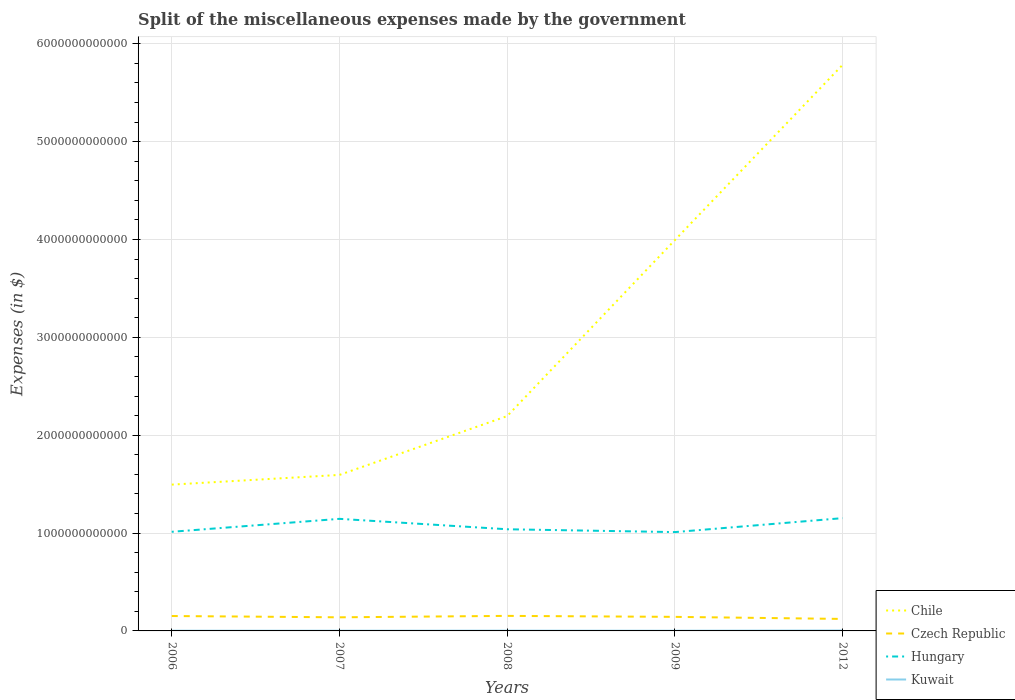Does the line corresponding to Hungary intersect with the line corresponding to Czech Republic?
Ensure brevity in your answer.  No. Across all years, what is the maximum miscellaneous expenses made by the government in Kuwait?
Offer a terse response. 1.95e+09. In which year was the miscellaneous expenses made by the government in Czech Republic maximum?
Your answer should be very brief. 2012. What is the total miscellaneous expenses made by the government in Kuwait in the graph?
Your response must be concise. 6.62e+08. What is the difference between the highest and the second highest miscellaneous expenses made by the government in Kuwait?
Offer a terse response. 2.01e+09. What is the difference between the highest and the lowest miscellaneous expenses made by the government in Chile?
Provide a succinct answer. 2. Is the miscellaneous expenses made by the government in Kuwait strictly greater than the miscellaneous expenses made by the government in Hungary over the years?
Make the answer very short. Yes. How many years are there in the graph?
Make the answer very short. 5. What is the difference between two consecutive major ticks on the Y-axis?
Your response must be concise. 1.00e+12. How many legend labels are there?
Your answer should be compact. 4. How are the legend labels stacked?
Your response must be concise. Vertical. What is the title of the graph?
Keep it short and to the point. Split of the miscellaneous expenses made by the government. What is the label or title of the Y-axis?
Your answer should be very brief. Expenses (in $). What is the Expenses (in $) in Chile in 2006?
Make the answer very short. 1.50e+12. What is the Expenses (in $) of Czech Republic in 2006?
Your answer should be very brief. 1.52e+11. What is the Expenses (in $) in Hungary in 2006?
Provide a short and direct response. 1.01e+12. What is the Expenses (in $) of Kuwait in 2006?
Your answer should be compact. 2.00e+09. What is the Expenses (in $) of Chile in 2007?
Provide a succinct answer. 1.59e+12. What is the Expenses (in $) of Czech Republic in 2007?
Offer a terse response. 1.39e+11. What is the Expenses (in $) in Hungary in 2007?
Your answer should be compact. 1.15e+12. What is the Expenses (in $) in Kuwait in 2007?
Offer a very short reply. 2.09e+09. What is the Expenses (in $) of Chile in 2008?
Your response must be concise. 2.20e+12. What is the Expenses (in $) of Czech Republic in 2008?
Offer a terse response. 1.54e+11. What is the Expenses (in $) in Hungary in 2008?
Offer a terse response. 1.04e+12. What is the Expenses (in $) of Kuwait in 2008?
Make the answer very short. 2.62e+09. What is the Expenses (in $) in Chile in 2009?
Give a very brief answer. 3.99e+12. What is the Expenses (in $) in Czech Republic in 2009?
Your response must be concise. 1.44e+11. What is the Expenses (in $) of Hungary in 2009?
Your answer should be very brief. 1.01e+12. What is the Expenses (in $) in Kuwait in 2009?
Your answer should be compact. 1.95e+09. What is the Expenses (in $) of Chile in 2012?
Provide a short and direct response. 5.78e+12. What is the Expenses (in $) in Czech Republic in 2012?
Keep it short and to the point. 1.22e+11. What is the Expenses (in $) in Hungary in 2012?
Provide a short and direct response. 1.15e+12. What is the Expenses (in $) of Kuwait in 2012?
Make the answer very short. 3.96e+09. Across all years, what is the maximum Expenses (in $) in Chile?
Keep it short and to the point. 5.78e+12. Across all years, what is the maximum Expenses (in $) in Czech Republic?
Ensure brevity in your answer.  1.54e+11. Across all years, what is the maximum Expenses (in $) in Hungary?
Provide a succinct answer. 1.15e+12. Across all years, what is the maximum Expenses (in $) in Kuwait?
Your response must be concise. 3.96e+09. Across all years, what is the minimum Expenses (in $) of Chile?
Provide a succinct answer. 1.50e+12. Across all years, what is the minimum Expenses (in $) in Czech Republic?
Give a very brief answer. 1.22e+11. Across all years, what is the minimum Expenses (in $) of Hungary?
Ensure brevity in your answer.  1.01e+12. Across all years, what is the minimum Expenses (in $) in Kuwait?
Offer a terse response. 1.95e+09. What is the total Expenses (in $) of Chile in the graph?
Give a very brief answer. 1.51e+13. What is the total Expenses (in $) of Czech Republic in the graph?
Your answer should be very brief. 7.11e+11. What is the total Expenses (in $) of Hungary in the graph?
Offer a very short reply. 5.36e+12. What is the total Expenses (in $) of Kuwait in the graph?
Provide a short and direct response. 1.26e+1. What is the difference between the Expenses (in $) in Chile in 2006 and that in 2007?
Make the answer very short. -9.92e+1. What is the difference between the Expenses (in $) in Czech Republic in 2006 and that in 2007?
Make the answer very short. 1.33e+1. What is the difference between the Expenses (in $) in Hungary in 2006 and that in 2007?
Offer a terse response. -1.32e+11. What is the difference between the Expenses (in $) of Kuwait in 2006 and that in 2007?
Offer a terse response. -8.40e+07. What is the difference between the Expenses (in $) of Chile in 2006 and that in 2008?
Your answer should be very brief. -7.00e+11. What is the difference between the Expenses (in $) in Czech Republic in 2006 and that in 2008?
Provide a succinct answer. -1.35e+09. What is the difference between the Expenses (in $) in Hungary in 2006 and that in 2008?
Your answer should be very brief. -2.59e+1. What is the difference between the Expenses (in $) of Kuwait in 2006 and that in 2008?
Keep it short and to the point. -6.12e+08. What is the difference between the Expenses (in $) in Chile in 2006 and that in 2009?
Offer a terse response. -2.50e+12. What is the difference between the Expenses (in $) in Czech Republic in 2006 and that in 2009?
Your answer should be very brief. 8.73e+09. What is the difference between the Expenses (in $) of Hungary in 2006 and that in 2009?
Offer a terse response. 3.08e+09. What is the difference between the Expenses (in $) of Chile in 2006 and that in 2012?
Your answer should be very brief. -4.29e+12. What is the difference between the Expenses (in $) in Czech Republic in 2006 and that in 2012?
Your answer should be very brief. 2.99e+1. What is the difference between the Expenses (in $) of Hungary in 2006 and that in 2012?
Ensure brevity in your answer.  -1.40e+11. What is the difference between the Expenses (in $) in Kuwait in 2006 and that in 2012?
Offer a very short reply. -1.96e+09. What is the difference between the Expenses (in $) of Chile in 2007 and that in 2008?
Provide a succinct answer. -6.01e+11. What is the difference between the Expenses (in $) in Czech Republic in 2007 and that in 2008?
Your response must be concise. -1.46e+1. What is the difference between the Expenses (in $) of Hungary in 2007 and that in 2008?
Your answer should be compact. 1.06e+11. What is the difference between the Expenses (in $) of Kuwait in 2007 and that in 2008?
Offer a very short reply. -5.28e+08. What is the difference between the Expenses (in $) of Chile in 2007 and that in 2009?
Your answer should be compact. -2.40e+12. What is the difference between the Expenses (in $) of Czech Republic in 2007 and that in 2009?
Ensure brevity in your answer.  -4.55e+09. What is the difference between the Expenses (in $) of Hungary in 2007 and that in 2009?
Your answer should be very brief. 1.35e+11. What is the difference between the Expenses (in $) of Kuwait in 2007 and that in 2009?
Offer a terse response. 1.34e+08. What is the difference between the Expenses (in $) of Chile in 2007 and that in 2012?
Give a very brief answer. -4.19e+12. What is the difference between the Expenses (in $) in Czech Republic in 2007 and that in 2012?
Make the answer very short. 1.66e+1. What is the difference between the Expenses (in $) in Hungary in 2007 and that in 2012?
Offer a terse response. -7.26e+09. What is the difference between the Expenses (in $) of Kuwait in 2007 and that in 2012?
Keep it short and to the point. -1.87e+09. What is the difference between the Expenses (in $) of Chile in 2008 and that in 2009?
Provide a short and direct response. -1.80e+12. What is the difference between the Expenses (in $) in Czech Republic in 2008 and that in 2009?
Keep it short and to the point. 1.01e+1. What is the difference between the Expenses (in $) in Hungary in 2008 and that in 2009?
Offer a very short reply. 2.90e+1. What is the difference between the Expenses (in $) of Kuwait in 2008 and that in 2009?
Give a very brief answer. 6.62e+08. What is the difference between the Expenses (in $) of Chile in 2008 and that in 2012?
Offer a very short reply. -3.59e+12. What is the difference between the Expenses (in $) in Czech Republic in 2008 and that in 2012?
Keep it short and to the point. 3.12e+1. What is the difference between the Expenses (in $) of Hungary in 2008 and that in 2012?
Provide a succinct answer. -1.14e+11. What is the difference between the Expenses (in $) in Kuwait in 2008 and that in 2012?
Offer a very short reply. -1.34e+09. What is the difference between the Expenses (in $) of Chile in 2009 and that in 2012?
Make the answer very short. -1.79e+12. What is the difference between the Expenses (in $) of Czech Republic in 2009 and that in 2012?
Your answer should be compact. 2.12e+1. What is the difference between the Expenses (in $) in Hungary in 2009 and that in 2012?
Offer a very short reply. -1.43e+11. What is the difference between the Expenses (in $) in Kuwait in 2009 and that in 2012?
Give a very brief answer. -2.01e+09. What is the difference between the Expenses (in $) of Chile in 2006 and the Expenses (in $) of Czech Republic in 2007?
Ensure brevity in your answer.  1.36e+12. What is the difference between the Expenses (in $) in Chile in 2006 and the Expenses (in $) in Hungary in 2007?
Offer a terse response. 3.50e+11. What is the difference between the Expenses (in $) in Chile in 2006 and the Expenses (in $) in Kuwait in 2007?
Offer a terse response. 1.49e+12. What is the difference between the Expenses (in $) in Czech Republic in 2006 and the Expenses (in $) in Hungary in 2007?
Make the answer very short. -9.93e+11. What is the difference between the Expenses (in $) of Czech Republic in 2006 and the Expenses (in $) of Kuwait in 2007?
Provide a short and direct response. 1.50e+11. What is the difference between the Expenses (in $) in Hungary in 2006 and the Expenses (in $) in Kuwait in 2007?
Provide a short and direct response. 1.01e+12. What is the difference between the Expenses (in $) in Chile in 2006 and the Expenses (in $) in Czech Republic in 2008?
Keep it short and to the point. 1.34e+12. What is the difference between the Expenses (in $) of Chile in 2006 and the Expenses (in $) of Hungary in 2008?
Your answer should be compact. 4.56e+11. What is the difference between the Expenses (in $) in Chile in 2006 and the Expenses (in $) in Kuwait in 2008?
Your answer should be very brief. 1.49e+12. What is the difference between the Expenses (in $) in Czech Republic in 2006 and the Expenses (in $) in Hungary in 2008?
Your answer should be compact. -8.86e+11. What is the difference between the Expenses (in $) of Czech Republic in 2006 and the Expenses (in $) of Kuwait in 2008?
Keep it short and to the point. 1.50e+11. What is the difference between the Expenses (in $) of Hungary in 2006 and the Expenses (in $) of Kuwait in 2008?
Offer a terse response. 1.01e+12. What is the difference between the Expenses (in $) of Chile in 2006 and the Expenses (in $) of Czech Republic in 2009?
Offer a terse response. 1.35e+12. What is the difference between the Expenses (in $) of Chile in 2006 and the Expenses (in $) of Hungary in 2009?
Keep it short and to the point. 4.85e+11. What is the difference between the Expenses (in $) of Chile in 2006 and the Expenses (in $) of Kuwait in 2009?
Offer a very short reply. 1.49e+12. What is the difference between the Expenses (in $) of Czech Republic in 2006 and the Expenses (in $) of Hungary in 2009?
Offer a very short reply. -8.58e+11. What is the difference between the Expenses (in $) in Czech Republic in 2006 and the Expenses (in $) in Kuwait in 2009?
Provide a short and direct response. 1.50e+11. What is the difference between the Expenses (in $) in Hungary in 2006 and the Expenses (in $) in Kuwait in 2009?
Provide a succinct answer. 1.01e+12. What is the difference between the Expenses (in $) in Chile in 2006 and the Expenses (in $) in Czech Republic in 2012?
Make the answer very short. 1.37e+12. What is the difference between the Expenses (in $) in Chile in 2006 and the Expenses (in $) in Hungary in 2012?
Keep it short and to the point. 3.42e+11. What is the difference between the Expenses (in $) of Chile in 2006 and the Expenses (in $) of Kuwait in 2012?
Provide a short and direct response. 1.49e+12. What is the difference between the Expenses (in $) in Czech Republic in 2006 and the Expenses (in $) in Hungary in 2012?
Offer a terse response. -1.00e+12. What is the difference between the Expenses (in $) of Czech Republic in 2006 and the Expenses (in $) of Kuwait in 2012?
Keep it short and to the point. 1.48e+11. What is the difference between the Expenses (in $) in Hungary in 2006 and the Expenses (in $) in Kuwait in 2012?
Make the answer very short. 1.01e+12. What is the difference between the Expenses (in $) in Chile in 2007 and the Expenses (in $) in Czech Republic in 2008?
Make the answer very short. 1.44e+12. What is the difference between the Expenses (in $) in Chile in 2007 and the Expenses (in $) in Hungary in 2008?
Ensure brevity in your answer.  5.55e+11. What is the difference between the Expenses (in $) of Chile in 2007 and the Expenses (in $) of Kuwait in 2008?
Offer a terse response. 1.59e+12. What is the difference between the Expenses (in $) in Czech Republic in 2007 and the Expenses (in $) in Hungary in 2008?
Keep it short and to the point. -9.00e+11. What is the difference between the Expenses (in $) in Czech Republic in 2007 and the Expenses (in $) in Kuwait in 2008?
Your answer should be very brief. 1.36e+11. What is the difference between the Expenses (in $) in Hungary in 2007 and the Expenses (in $) in Kuwait in 2008?
Your answer should be very brief. 1.14e+12. What is the difference between the Expenses (in $) of Chile in 2007 and the Expenses (in $) of Czech Republic in 2009?
Keep it short and to the point. 1.45e+12. What is the difference between the Expenses (in $) in Chile in 2007 and the Expenses (in $) in Hungary in 2009?
Ensure brevity in your answer.  5.84e+11. What is the difference between the Expenses (in $) of Chile in 2007 and the Expenses (in $) of Kuwait in 2009?
Your answer should be very brief. 1.59e+12. What is the difference between the Expenses (in $) in Czech Republic in 2007 and the Expenses (in $) in Hungary in 2009?
Offer a terse response. -8.71e+11. What is the difference between the Expenses (in $) in Czech Republic in 2007 and the Expenses (in $) in Kuwait in 2009?
Provide a succinct answer. 1.37e+11. What is the difference between the Expenses (in $) of Hungary in 2007 and the Expenses (in $) of Kuwait in 2009?
Provide a short and direct response. 1.14e+12. What is the difference between the Expenses (in $) of Chile in 2007 and the Expenses (in $) of Czech Republic in 2012?
Keep it short and to the point. 1.47e+12. What is the difference between the Expenses (in $) in Chile in 2007 and the Expenses (in $) in Hungary in 2012?
Provide a short and direct response. 4.42e+11. What is the difference between the Expenses (in $) in Chile in 2007 and the Expenses (in $) in Kuwait in 2012?
Your answer should be very brief. 1.59e+12. What is the difference between the Expenses (in $) in Czech Republic in 2007 and the Expenses (in $) in Hungary in 2012?
Your answer should be very brief. -1.01e+12. What is the difference between the Expenses (in $) in Czech Republic in 2007 and the Expenses (in $) in Kuwait in 2012?
Give a very brief answer. 1.35e+11. What is the difference between the Expenses (in $) of Hungary in 2007 and the Expenses (in $) of Kuwait in 2012?
Your response must be concise. 1.14e+12. What is the difference between the Expenses (in $) in Chile in 2008 and the Expenses (in $) in Czech Republic in 2009?
Your answer should be compact. 2.05e+12. What is the difference between the Expenses (in $) of Chile in 2008 and the Expenses (in $) of Hungary in 2009?
Ensure brevity in your answer.  1.19e+12. What is the difference between the Expenses (in $) in Chile in 2008 and the Expenses (in $) in Kuwait in 2009?
Ensure brevity in your answer.  2.19e+12. What is the difference between the Expenses (in $) of Czech Republic in 2008 and the Expenses (in $) of Hungary in 2009?
Your answer should be very brief. -8.56e+11. What is the difference between the Expenses (in $) of Czech Republic in 2008 and the Expenses (in $) of Kuwait in 2009?
Your response must be concise. 1.52e+11. What is the difference between the Expenses (in $) in Hungary in 2008 and the Expenses (in $) in Kuwait in 2009?
Give a very brief answer. 1.04e+12. What is the difference between the Expenses (in $) of Chile in 2008 and the Expenses (in $) of Czech Republic in 2012?
Provide a short and direct response. 2.07e+12. What is the difference between the Expenses (in $) of Chile in 2008 and the Expenses (in $) of Hungary in 2012?
Your response must be concise. 1.04e+12. What is the difference between the Expenses (in $) of Chile in 2008 and the Expenses (in $) of Kuwait in 2012?
Your answer should be very brief. 2.19e+12. What is the difference between the Expenses (in $) of Czech Republic in 2008 and the Expenses (in $) of Hungary in 2012?
Offer a terse response. -9.99e+11. What is the difference between the Expenses (in $) of Czech Republic in 2008 and the Expenses (in $) of Kuwait in 2012?
Offer a very short reply. 1.50e+11. What is the difference between the Expenses (in $) of Hungary in 2008 and the Expenses (in $) of Kuwait in 2012?
Offer a very short reply. 1.03e+12. What is the difference between the Expenses (in $) of Chile in 2009 and the Expenses (in $) of Czech Republic in 2012?
Your answer should be very brief. 3.87e+12. What is the difference between the Expenses (in $) in Chile in 2009 and the Expenses (in $) in Hungary in 2012?
Ensure brevity in your answer.  2.84e+12. What is the difference between the Expenses (in $) in Chile in 2009 and the Expenses (in $) in Kuwait in 2012?
Make the answer very short. 3.99e+12. What is the difference between the Expenses (in $) of Czech Republic in 2009 and the Expenses (in $) of Hungary in 2012?
Ensure brevity in your answer.  -1.01e+12. What is the difference between the Expenses (in $) in Czech Republic in 2009 and the Expenses (in $) in Kuwait in 2012?
Give a very brief answer. 1.40e+11. What is the difference between the Expenses (in $) in Hungary in 2009 and the Expenses (in $) in Kuwait in 2012?
Your answer should be very brief. 1.01e+12. What is the average Expenses (in $) of Chile per year?
Your answer should be very brief. 3.01e+12. What is the average Expenses (in $) in Czech Republic per year?
Your answer should be very brief. 1.42e+11. What is the average Expenses (in $) of Hungary per year?
Your response must be concise. 1.07e+12. What is the average Expenses (in $) of Kuwait per year?
Your answer should be very brief. 2.52e+09. In the year 2006, what is the difference between the Expenses (in $) in Chile and Expenses (in $) in Czech Republic?
Provide a short and direct response. 1.34e+12. In the year 2006, what is the difference between the Expenses (in $) of Chile and Expenses (in $) of Hungary?
Make the answer very short. 4.82e+11. In the year 2006, what is the difference between the Expenses (in $) of Chile and Expenses (in $) of Kuwait?
Your answer should be compact. 1.49e+12. In the year 2006, what is the difference between the Expenses (in $) in Czech Republic and Expenses (in $) in Hungary?
Ensure brevity in your answer.  -8.61e+11. In the year 2006, what is the difference between the Expenses (in $) of Czech Republic and Expenses (in $) of Kuwait?
Make the answer very short. 1.50e+11. In the year 2006, what is the difference between the Expenses (in $) in Hungary and Expenses (in $) in Kuwait?
Make the answer very short. 1.01e+12. In the year 2007, what is the difference between the Expenses (in $) of Chile and Expenses (in $) of Czech Republic?
Your answer should be compact. 1.46e+12. In the year 2007, what is the difference between the Expenses (in $) in Chile and Expenses (in $) in Hungary?
Your answer should be very brief. 4.49e+11. In the year 2007, what is the difference between the Expenses (in $) of Chile and Expenses (in $) of Kuwait?
Your response must be concise. 1.59e+12. In the year 2007, what is the difference between the Expenses (in $) in Czech Republic and Expenses (in $) in Hungary?
Ensure brevity in your answer.  -1.01e+12. In the year 2007, what is the difference between the Expenses (in $) of Czech Republic and Expenses (in $) of Kuwait?
Provide a succinct answer. 1.37e+11. In the year 2007, what is the difference between the Expenses (in $) in Hungary and Expenses (in $) in Kuwait?
Ensure brevity in your answer.  1.14e+12. In the year 2008, what is the difference between the Expenses (in $) in Chile and Expenses (in $) in Czech Republic?
Make the answer very short. 2.04e+12. In the year 2008, what is the difference between the Expenses (in $) in Chile and Expenses (in $) in Hungary?
Ensure brevity in your answer.  1.16e+12. In the year 2008, what is the difference between the Expenses (in $) of Chile and Expenses (in $) of Kuwait?
Ensure brevity in your answer.  2.19e+12. In the year 2008, what is the difference between the Expenses (in $) in Czech Republic and Expenses (in $) in Hungary?
Provide a succinct answer. -8.85e+11. In the year 2008, what is the difference between the Expenses (in $) in Czech Republic and Expenses (in $) in Kuwait?
Provide a succinct answer. 1.51e+11. In the year 2008, what is the difference between the Expenses (in $) of Hungary and Expenses (in $) of Kuwait?
Offer a terse response. 1.04e+12. In the year 2009, what is the difference between the Expenses (in $) of Chile and Expenses (in $) of Czech Republic?
Your answer should be compact. 3.85e+12. In the year 2009, what is the difference between the Expenses (in $) in Chile and Expenses (in $) in Hungary?
Offer a very short reply. 2.98e+12. In the year 2009, what is the difference between the Expenses (in $) in Chile and Expenses (in $) in Kuwait?
Make the answer very short. 3.99e+12. In the year 2009, what is the difference between the Expenses (in $) of Czech Republic and Expenses (in $) of Hungary?
Offer a very short reply. -8.66e+11. In the year 2009, what is the difference between the Expenses (in $) of Czech Republic and Expenses (in $) of Kuwait?
Make the answer very short. 1.42e+11. In the year 2009, what is the difference between the Expenses (in $) in Hungary and Expenses (in $) in Kuwait?
Offer a very short reply. 1.01e+12. In the year 2012, what is the difference between the Expenses (in $) of Chile and Expenses (in $) of Czech Republic?
Provide a succinct answer. 5.66e+12. In the year 2012, what is the difference between the Expenses (in $) in Chile and Expenses (in $) in Hungary?
Give a very brief answer. 4.63e+12. In the year 2012, what is the difference between the Expenses (in $) of Chile and Expenses (in $) of Kuwait?
Provide a succinct answer. 5.78e+12. In the year 2012, what is the difference between the Expenses (in $) in Czech Republic and Expenses (in $) in Hungary?
Your answer should be very brief. -1.03e+12. In the year 2012, what is the difference between the Expenses (in $) in Czech Republic and Expenses (in $) in Kuwait?
Offer a terse response. 1.19e+11. In the year 2012, what is the difference between the Expenses (in $) in Hungary and Expenses (in $) in Kuwait?
Keep it short and to the point. 1.15e+12. What is the ratio of the Expenses (in $) of Chile in 2006 to that in 2007?
Provide a short and direct response. 0.94. What is the ratio of the Expenses (in $) in Czech Republic in 2006 to that in 2007?
Provide a succinct answer. 1.1. What is the ratio of the Expenses (in $) of Hungary in 2006 to that in 2007?
Your response must be concise. 0.88. What is the ratio of the Expenses (in $) in Kuwait in 2006 to that in 2007?
Keep it short and to the point. 0.96. What is the ratio of the Expenses (in $) in Chile in 2006 to that in 2008?
Your response must be concise. 0.68. What is the ratio of the Expenses (in $) of Hungary in 2006 to that in 2008?
Provide a succinct answer. 0.98. What is the ratio of the Expenses (in $) of Kuwait in 2006 to that in 2008?
Give a very brief answer. 0.77. What is the ratio of the Expenses (in $) in Chile in 2006 to that in 2009?
Your response must be concise. 0.37. What is the ratio of the Expenses (in $) in Czech Republic in 2006 to that in 2009?
Ensure brevity in your answer.  1.06. What is the ratio of the Expenses (in $) of Hungary in 2006 to that in 2009?
Your answer should be very brief. 1. What is the ratio of the Expenses (in $) in Kuwait in 2006 to that in 2009?
Keep it short and to the point. 1.03. What is the ratio of the Expenses (in $) in Chile in 2006 to that in 2012?
Your answer should be very brief. 0.26. What is the ratio of the Expenses (in $) in Czech Republic in 2006 to that in 2012?
Give a very brief answer. 1.24. What is the ratio of the Expenses (in $) in Hungary in 2006 to that in 2012?
Ensure brevity in your answer.  0.88. What is the ratio of the Expenses (in $) of Kuwait in 2006 to that in 2012?
Ensure brevity in your answer.  0.51. What is the ratio of the Expenses (in $) of Chile in 2007 to that in 2008?
Ensure brevity in your answer.  0.73. What is the ratio of the Expenses (in $) of Czech Republic in 2007 to that in 2008?
Your response must be concise. 0.9. What is the ratio of the Expenses (in $) in Hungary in 2007 to that in 2008?
Provide a succinct answer. 1.1. What is the ratio of the Expenses (in $) in Kuwait in 2007 to that in 2008?
Your response must be concise. 0.8. What is the ratio of the Expenses (in $) of Chile in 2007 to that in 2009?
Ensure brevity in your answer.  0.4. What is the ratio of the Expenses (in $) in Czech Republic in 2007 to that in 2009?
Your response must be concise. 0.97. What is the ratio of the Expenses (in $) in Hungary in 2007 to that in 2009?
Offer a terse response. 1.13. What is the ratio of the Expenses (in $) of Kuwait in 2007 to that in 2009?
Provide a short and direct response. 1.07. What is the ratio of the Expenses (in $) of Chile in 2007 to that in 2012?
Offer a very short reply. 0.28. What is the ratio of the Expenses (in $) of Czech Republic in 2007 to that in 2012?
Keep it short and to the point. 1.14. What is the ratio of the Expenses (in $) in Hungary in 2007 to that in 2012?
Keep it short and to the point. 0.99. What is the ratio of the Expenses (in $) in Kuwait in 2007 to that in 2012?
Provide a short and direct response. 0.53. What is the ratio of the Expenses (in $) of Chile in 2008 to that in 2009?
Your response must be concise. 0.55. What is the ratio of the Expenses (in $) in Czech Republic in 2008 to that in 2009?
Your answer should be very brief. 1.07. What is the ratio of the Expenses (in $) of Hungary in 2008 to that in 2009?
Keep it short and to the point. 1.03. What is the ratio of the Expenses (in $) of Kuwait in 2008 to that in 2009?
Make the answer very short. 1.34. What is the ratio of the Expenses (in $) in Chile in 2008 to that in 2012?
Offer a terse response. 0.38. What is the ratio of the Expenses (in $) of Czech Republic in 2008 to that in 2012?
Your answer should be very brief. 1.26. What is the ratio of the Expenses (in $) in Hungary in 2008 to that in 2012?
Your response must be concise. 0.9. What is the ratio of the Expenses (in $) in Kuwait in 2008 to that in 2012?
Offer a very short reply. 0.66. What is the ratio of the Expenses (in $) in Chile in 2009 to that in 2012?
Keep it short and to the point. 0.69. What is the ratio of the Expenses (in $) of Czech Republic in 2009 to that in 2012?
Offer a terse response. 1.17. What is the ratio of the Expenses (in $) of Hungary in 2009 to that in 2012?
Ensure brevity in your answer.  0.88. What is the ratio of the Expenses (in $) of Kuwait in 2009 to that in 2012?
Provide a short and direct response. 0.49. What is the difference between the highest and the second highest Expenses (in $) of Chile?
Make the answer very short. 1.79e+12. What is the difference between the highest and the second highest Expenses (in $) in Czech Republic?
Ensure brevity in your answer.  1.35e+09. What is the difference between the highest and the second highest Expenses (in $) in Hungary?
Ensure brevity in your answer.  7.26e+09. What is the difference between the highest and the second highest Expenses (in $) in Kuwait?
Give a very brief answer. 1.34e+09. What is the difference between the highest and the lowest Expenses (in $) in Chile?
Ensure brevity in your answer.  4.29e+12. What is the difference between the highest and the lowest Expenses (in $) of Czech Republic?
Offer a very short reply. 3.12e+1. What is the difference between the highest and the lowest Expenses (in $) in Hungary?
Your response must be concise. 1.43e+11. What is the difference between the highest and the lowest Expenses (in $) in Kuwait?
Provide a short and direct response. 2.01e+09. 